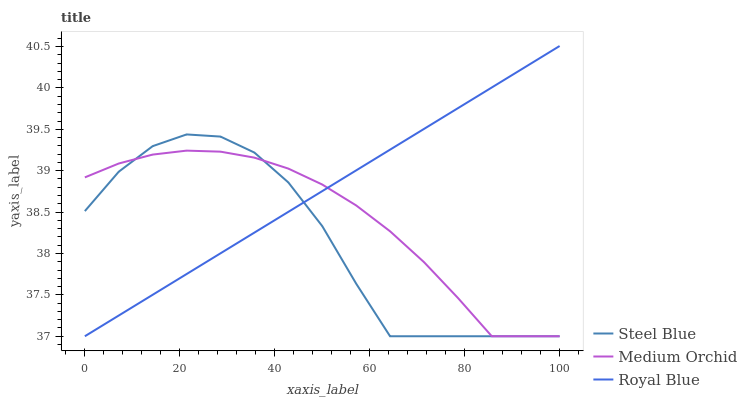Does Steel Blue have the minimum area under the curve?
Answer yes or no. Yes. Does Royal Blue have the maximum area under the curve?
Answer yes or no. Yes. Does Medium Orchid have the minimum area under the curve?
Answer yes or no. No. Does Medium Orchid have the maximum area under the curve?
Answer yes or no. No. Is Royal Blue the smoothest?
Answer yes or no. Yes. Is Steel Blue the roughest?
Answer yes or no. Yes. Is Medium Orchid the smoothest?
Answer yes or no. No. Is Medium Orchid the roughest?
Answer yes or no. No. Does Royal Blue have the lowest value?
Answer yes or no. Yes. Does Royal Blue have the highest value?
Answer yes or no. Yes. Does Steel Blue have the highest value?
Answer yes or no. No. Does Royal Blue intersect Medium Orchid?
Answer yes or no. Yes. Is Royal Blue less than Medium Orchid?
Answer yes or no. No. Is Royal Blue greater than Medium Orchid?
Answer yes or no. No. 